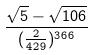<formula> <loc_0><loc_0><loc_500><loc_500>\frac { \sqrt { 5 } - \sqrt { 1 0 6 } } { ( \frac { 2 } { 4 2 9 } ) ^ { 3 6 6 } }</formula> 